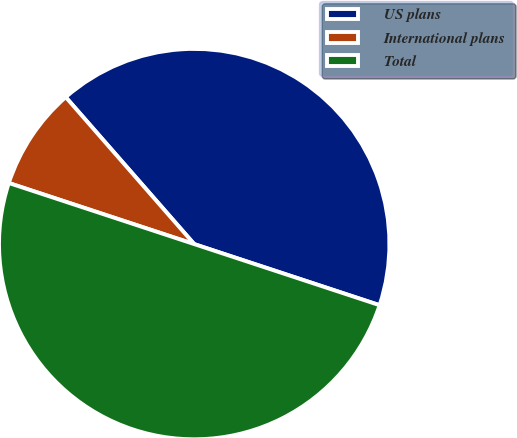<chart> <loc_0><loc_0><loc_500><loc_500><pie_chart><fcel>US plans<fcel>International plans<fcel>Total<nl><fcel>41.5%<fcel>8.5%<fcel>50.0%<nl></chart> 